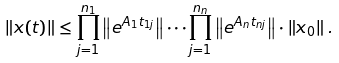Convert formula to latex. <formula><loc_0><loc_0><loc_500><loc_500>\left \| x ( t ) \right \| \leq \prod _ { j = 1 } ^ { n _ { 1 } } \left \| e ^ { A _ { 1 } t _ { 1 j } } \right \| \cdots \prod _ { j = 1 } ^ { n _ { n } } \left \| e ^ { A _ { n } t _ { n j } } \right \| \cdot \left \| x _ { 0 } \right \| .</formula> 